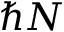Convert formula to latex. <formula><loc_0><loc_0><loc_500><loc_500>\hbar { N }</formula> 